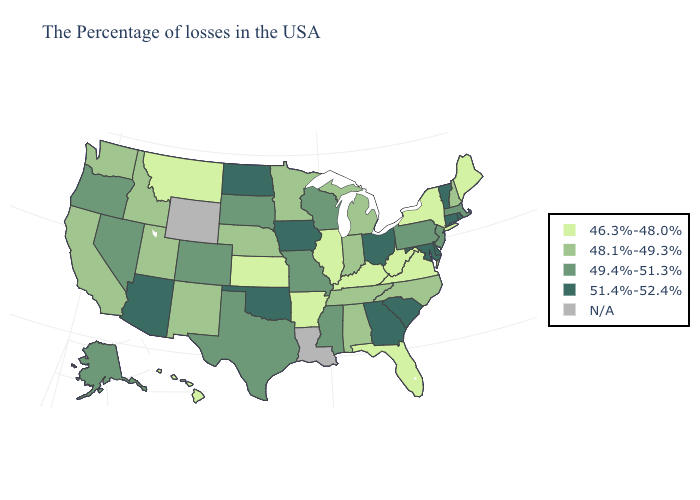Does Delaware have the highest value in the South?
Quick response, please. Yes. Name the states that have a value in the range N/A?
Give a very brief answer. Louisiana, Wyoming. Does Kansas have the lowest value in the MidWest?
Write a very short answer. Yes. What is the lowest value in the West?
Concise answer only. 46.3%-48.0%. What is the highest value in states that border Massachusetts?
Concise answer only. 51.4%-52.4%. Name the states that have a value in the range 51.4%-52.4%?
Concise answer only. Rhode Island, Vermont, Connecticut, Delaware, Maryland, South Carolina, Ohio, Georgia, Iowa, Oklahoma, North Dakota, Arizona. Does the map have missing data?
Give a very brief answer. Yes. What is the value of Wisconsin?
Short answer required. 49.4%-51.3%. Name the states that have a value in the range N/A?
Be succinct. Louisiana, Wyoming. What is the lowest value in states that border Minnesota?
Short answer required. 49.4%-51.3%. Which states have the lowest value in the USA?
Short answer required. Maine, New York, Virginia, West Virginia, Florida, Kentucky, Illinois, Arkansas, Kansas, Montana, Hawaii. What is the value of Nebraska?
Short answer required. 48.1%-49.3%. What is the highest value in the USA?
Answer briefly. 51.4%-52.4%. What is the value of Michigan?
Give a very brief answer. 48.1%-49.3%. 